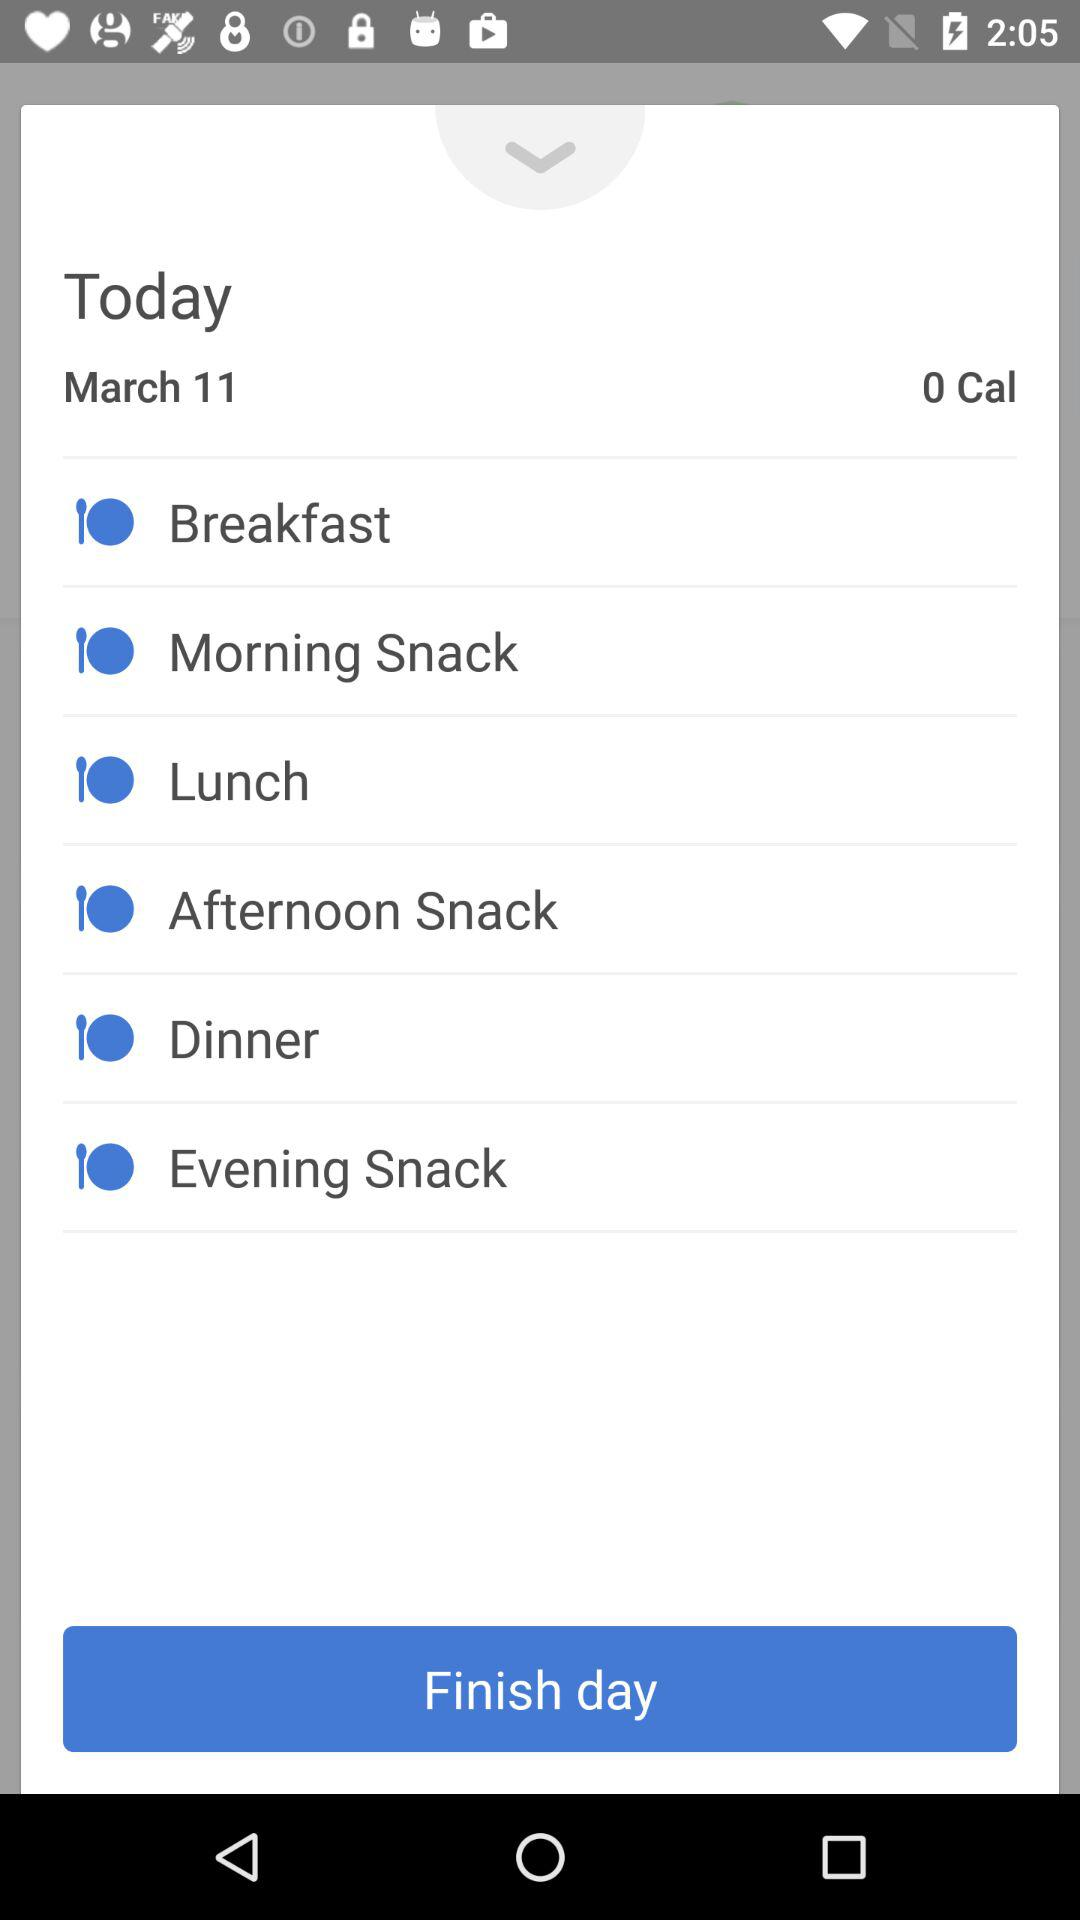What is the date today? The date today is March 11. 